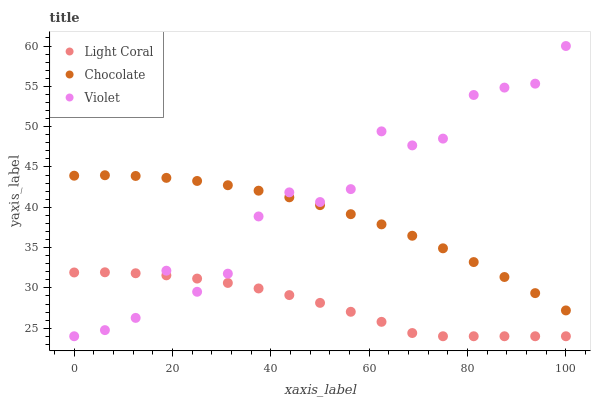Does Light Coral have the minimum area under the curve?
Answer yes or no. Yes. Does Violet have the maximum area under the curve?
Answer yes or no. Yes. Does Chocolate have the minimum area under the curve?
Answer yes or no. No. Does Chocolate have the maximum area under the curve?
Answer yes or no. No. Is Chocolate the smoothest?
Answer yes or no. Yes. Is Violet the roughest?
Answer yes or no. Yes. Is Violet the smoothest?
Answer yes or no. No. Is Chocolate the roughest?
Answer yes or no. No. Does Light Coral have the lowest value?
Answer yes or no. Yes. Does Chocolate have the lowest value?
Answer yes or no. No. Does Violet have the highest value?
Answer yes or no. Yes. Does Chocolate have the highest value?
Answer yes or no. No. Is Light Coral less than Chocolate?
Answer yes or no. Yes. Is Chocolate greater than Light Coral?
Answer yes or no. Yes. Does Violet intersect Light Coral?
Answer yes or no. Yes. Is Violet less than Light Coral?
Answer yes or no. No. Is Violet greater than Light Coral?
Answer yes or no. No. Does Light Coral intersect Chocolate?
Answer yes or no. No. 